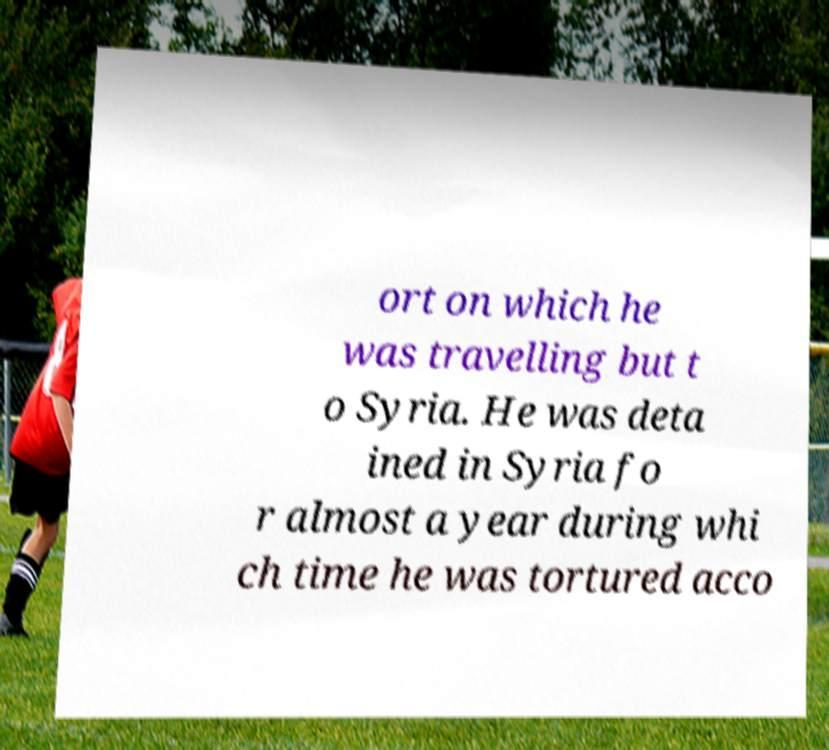Please read and relay the text visible in this image. What does it say? ort on which he was travelling but t o Syria. He was deta ined in Syria fo r almost a year during whi ch time he was tortured acco 